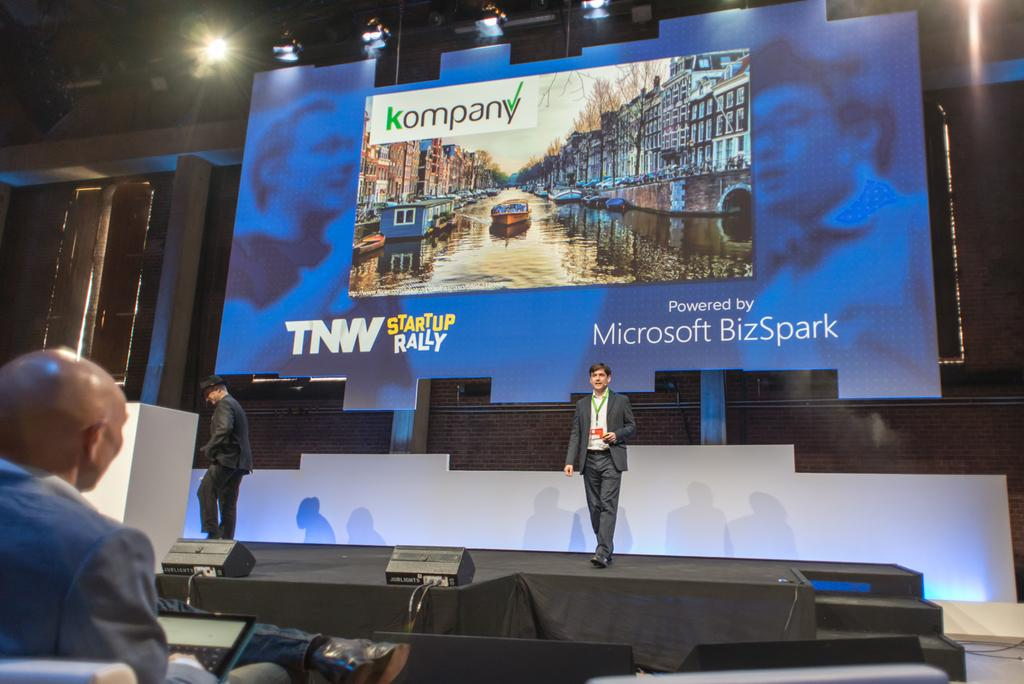<image>
Describe the image concisely. a Microsoft BizSpark screen behind a man doing a presentation 